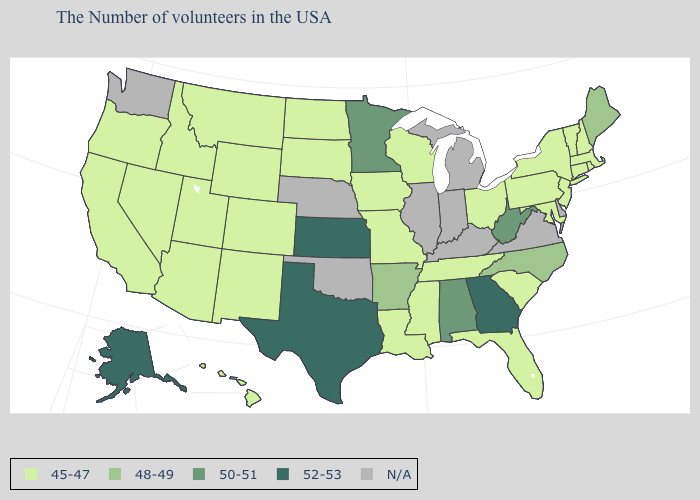Does Kansas have the highest value in the MidWest?
Concise answer only. Yes. Among the states that border Utah , which have the lowest value?
Concise answer only. Wyoming, Colorado, New Mexico, Arizona, Idaho, Nevada. What is the value of Kentucky?
Answer briefly. N/A. Does Maryland have the lowest value in the South?
Be succinct. Yes. Name the states that have a value in the range 52-53?
Quick response, please. Georgia, Kansas, Texas, Alaska. What is the value of Arkansas?
Be succinct. 48-49. Among the states that border Montana , which have the highest value?
Keep it brief. South Dakota, North Dakota, Wyoming, Idaho. Among the states that border Iowa , which have the lowest value?
Answer briefly. Wisconsin, Missouri, South Dakota. Among the states that border Texas , does Arkansas have the lowest value?
Concise answer only. No. What is the value of Virginia?
Quick response, please. N/A. What is the value of Massachusetts?
Give a very brief answer. 45-47. Does Kansas have the highest value in the MidWest?
Concise answer only. Yes. Name the states that have a value in the range 52-53?
Quick response, please. Georgia, Kansas, Texas, Alaska. What is the highest value in the Northeast ?
Concise answer only. 48-49. 